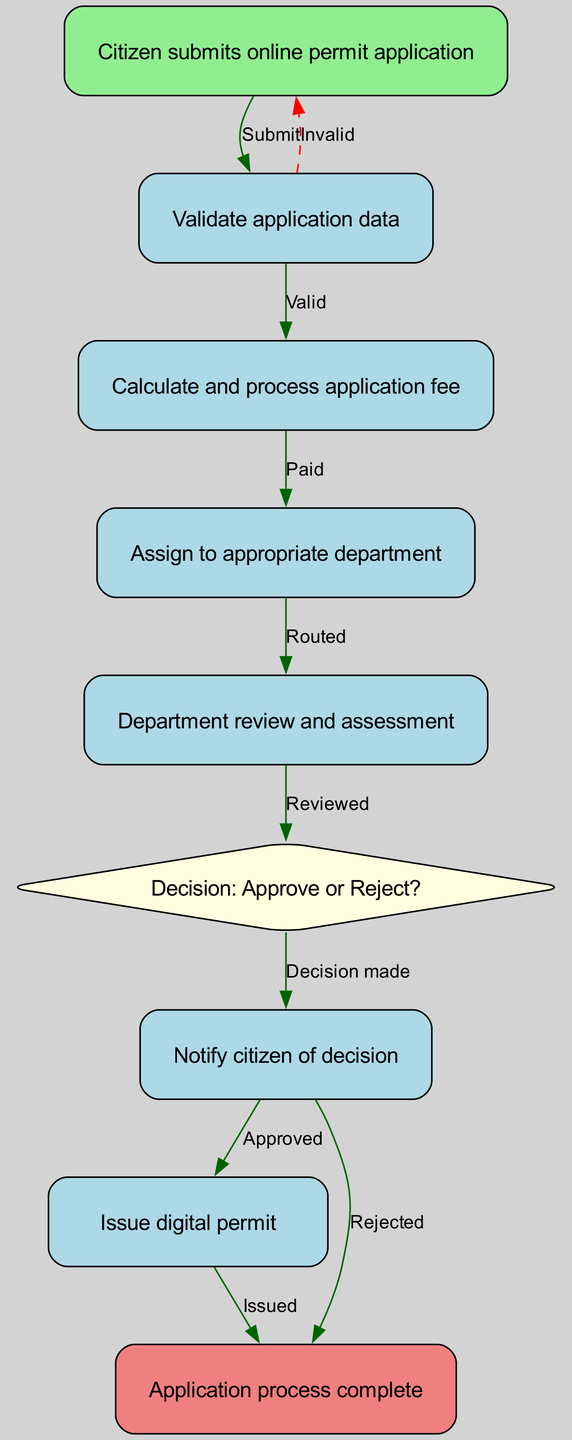What is the first step in the workflow? The first step in the workflow, depicted as the first node in the diagram, is "Citizen submits online permit application." This is where the process begins.
Answer: Citizen submits online permit application How many nodes are in the diagram? To find the total number of nodes, we can count each unique step in the workflow as depicted in the graph data. There are nine nodes listed in the "nodes" section of the data.
Answer: 9 What color represents the decision node? The decision node is represented in the diagram as a diamond shape filled with light yellow color. This helps distinguish it from regular process nodes.
Answer: light yellow What happens if the application data is invalid? If the application data is invalid, the diagram shows that the workflow would return to the "Citizen submits online permit application." This represents a looping back to the start to correct the issues.
Answer: Return to start Which node does the application fee payment lead to? Upon successfully processing the application fee, the workflow leads to the next node, which is "Assign to appropriate department." This continues the flow of the process after fee payment.
Answer: Assign to appropriate department How many edges are there in the diagram? The edges represent the connections between nodes. By counting the connections listed in the "edges" section of the diagram data, we find there are ten edges.
Answer: 10 What is the outcome if the decision is to approve? If the decision is made to approve the application, the workflow will lead to the "Notify citizen of decision" node, and subsequently to the "Issue digital permit" node. This indicates the next steps following an approval.
Answer: Notify citizen of decision What shape is used for the start and end nodes? The start node is depicted as a rectangle with a light green fill color, while the end node is a rectangle as well with a light coral fill color. Both shapes are rectangles but differ in color depending on their role in the process.
Answer: Rectangle What is the relationship between the review and decision nodes? The relationship between the "Department review and assessment" node and the "Decision: Approve or Reject?" node is depicted as a transition pathway, indicating that a review must occur before a decision can be made. This shows a direct flow from the review to decision-making.
Answer: Reviewed 